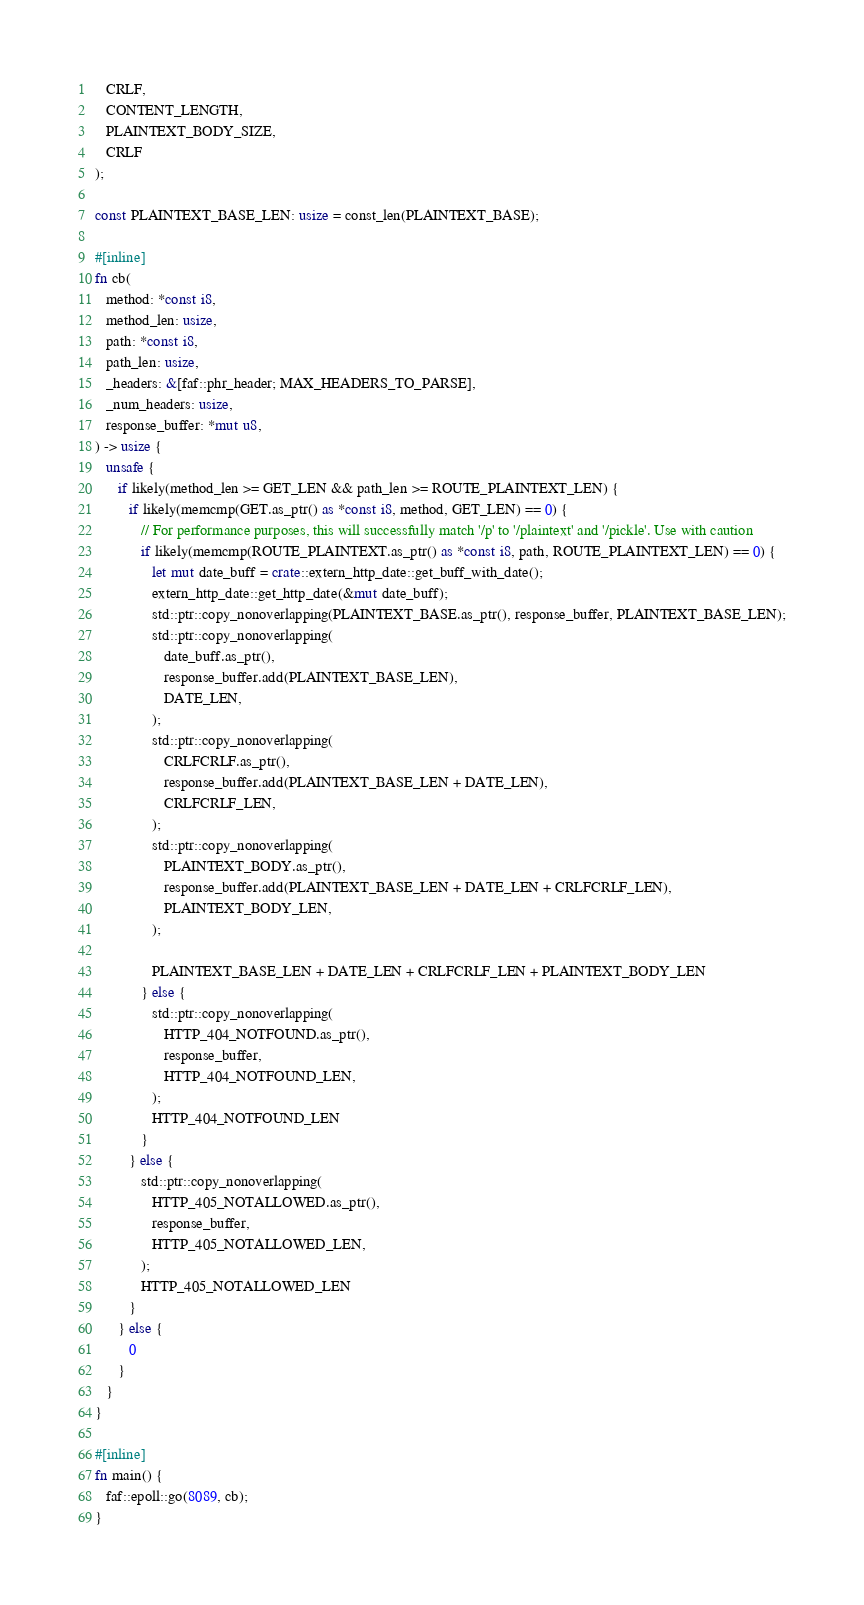Convert code to text. <code><loc_0><loc_0><loc_500><loc_500><_Rust_>   CRLF,
   CONTENT_LENGTH,
   PLAINTEXT_BODY_SIZE,
   CRLF
);

const PLAINTEXT_BASE_LEN: usize = const_len(PLAINTEXT_BASE);

#[inline]
fn cb(
   method: *const i8,
   method_len: usize,
   path: *const i8,
   path_len: usize,
   _headers: &[faf::phr_header; MAX_HEADERS_TO_PARSE],
   _num_headers: usize,
   response_buffer: *mut u8,
) -> usize {
   unsafe {
      if likely(method_len >= GET_LEN && path_len >= ROUTE_PLAINTEXT_LEN) {
         if likely(memcmp(GET.as_ptr() as *const i8, method, GET_LEN) == 0) {
            // For performance purposes, this will successfully match '/p' to '/plaintext' and '/pickle'. Use with caution
            if likely(memcmp(ROUTE_PLAINTEXT.as_ptr() as *const i8, path, ROUTE_PLAINTEXT_LEN) == 0) {
               let mut date_buff = crate::extern_http_date::get_buff_with_date();
               extern_http_date::get_http_date(&mut date_buff);
               std::ptr::copy_nonoverlapping(PLAINTEXT_BASE.as_ptr(), response_buffer, PLAINTEXT_BASE_LEN);
               std::ptr::copy_nonoverlapping(
                  date_buff.as_ptr(),
                  response_buffer.add(PLAINTEXT_BASE_LEN),
                  DATE_LEN,
               );
               std::ptr::copy_nonoverlapping(
                  CRLFCRLF.as_ptr(),
                  response_buffer.add(PLAINTEXT_BASE_LEN + DATE_LEN),
                  CRLFCRLF_LEN,
               );
               std::ptr::copy_nonoverlapping(
                  PLAINTEXT_BODY.as_ptr(),
                  response_buffer.add(PLAINTEXT_BASE_LEN + DATE_LEN + CRLFCRLF_LEN),
                  PLAINTEXT_BODY_LEN,
               );

               PLAINTEXT_BASE_LEN + DATE_LEN + CRLFCRLF_LEN + PLAINTEXT_BODY_LEN
            } else {
               std::ptr::copy_nonoverlapping(
                  HTTP_404_NOTFOUND.as_ptr(),
                  response_buffer,
                  HTTP_404_NOTFOUND_LEN,
               );
               HTTP_404_NOTFOUND_LEN
            }
         } else {
            std::ptr::copy_nonoverlapping(
               HTTP_405_NOTALLOWED.as_ptr(),
               response_buffer,
               HTTP_405_NOTALLOWED_LEN,
            );
            HTTP_405_NOTALLOWED_LEN
         }
      } else {
         0
      }
   }
}

#[inline]
fn main() {
   faf::epoll::go(8089, cb);
}
</code> 